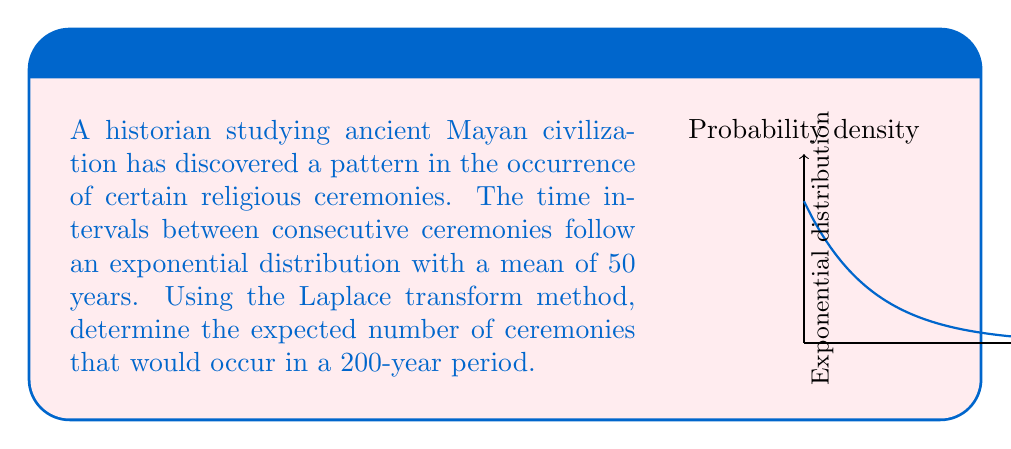Could you help me with this problem? Let's approach this step-by-step using the Laplace transform method:

1) First, we need to identify the rate parameter λ of the exponential distribution. Given that the mean is 50 years:

   $\lambda = \frac{1}{\text{mean}} = \frac{1}{50} = 0.02$ per year

2) The probability density function of the exponential distribution is:

   $f(t) = \lambda e^{-\lambda t} = 0.02e^{-0.02t}$

3) The Laplace transform of this function is:

   $F(s) = \mathcal{L}\{f(t)\} = \frac{\lambda}{s + \lambda} = \frac{0.02}{s + 0.02}$

4) The expected number of events in time T is given by the renewal function:

   $m(T) = \mathcal{L}^{-1}\{\frac{F(s)}{s(1-F(s))}\}$

5) Substituting our F(s):

   $m(T) = \mathcal{L}^{-1}\{\frac{0.02}{s(s + 0.02)} \cdot \frac{s + 0.02}{s}\} = \mathcal{L}^{-1}\{\frac{0.02}{s^2}\}$

6) The inverse Laplace transform of $\frac{1}{s^2}$ is t, so:

   $m(T) = 0.02T$

7) For T = 200 years:

   $m(200) = 0.02 \cdot 200 = 4$

Therefore, the expected number of ceremonies in a 200-year period is 4.
Answer: 4 ceremonies 